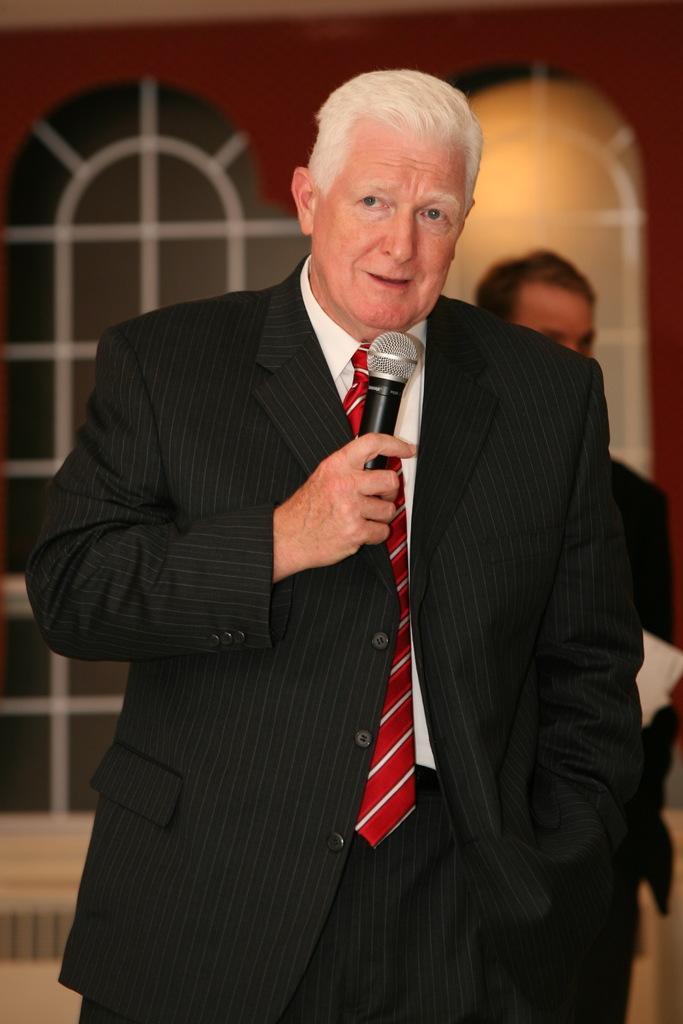In one or two sentences, can you explain what this image depicts? In this picture there is a old man holding a microphone and smiling looking at someone else is also another person standing in the backdrop. 